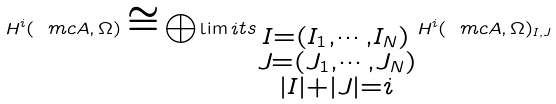<formula> <loc_0><loc_0><loc_500><loc_500>H ^ { i } ( \ m c A , \Omega ) \cong \bigoplus \lim i t s _ { \substack { I = ( I _ { 1 } , \cdots , I _ { N } ) \\ J = ( J _ { 1 } , \cdots , J _ { N } ) \\ | I | + | J | = i } } H ^ { i } ( \ m c A , \Omega ) _ { I , J }</formula> 